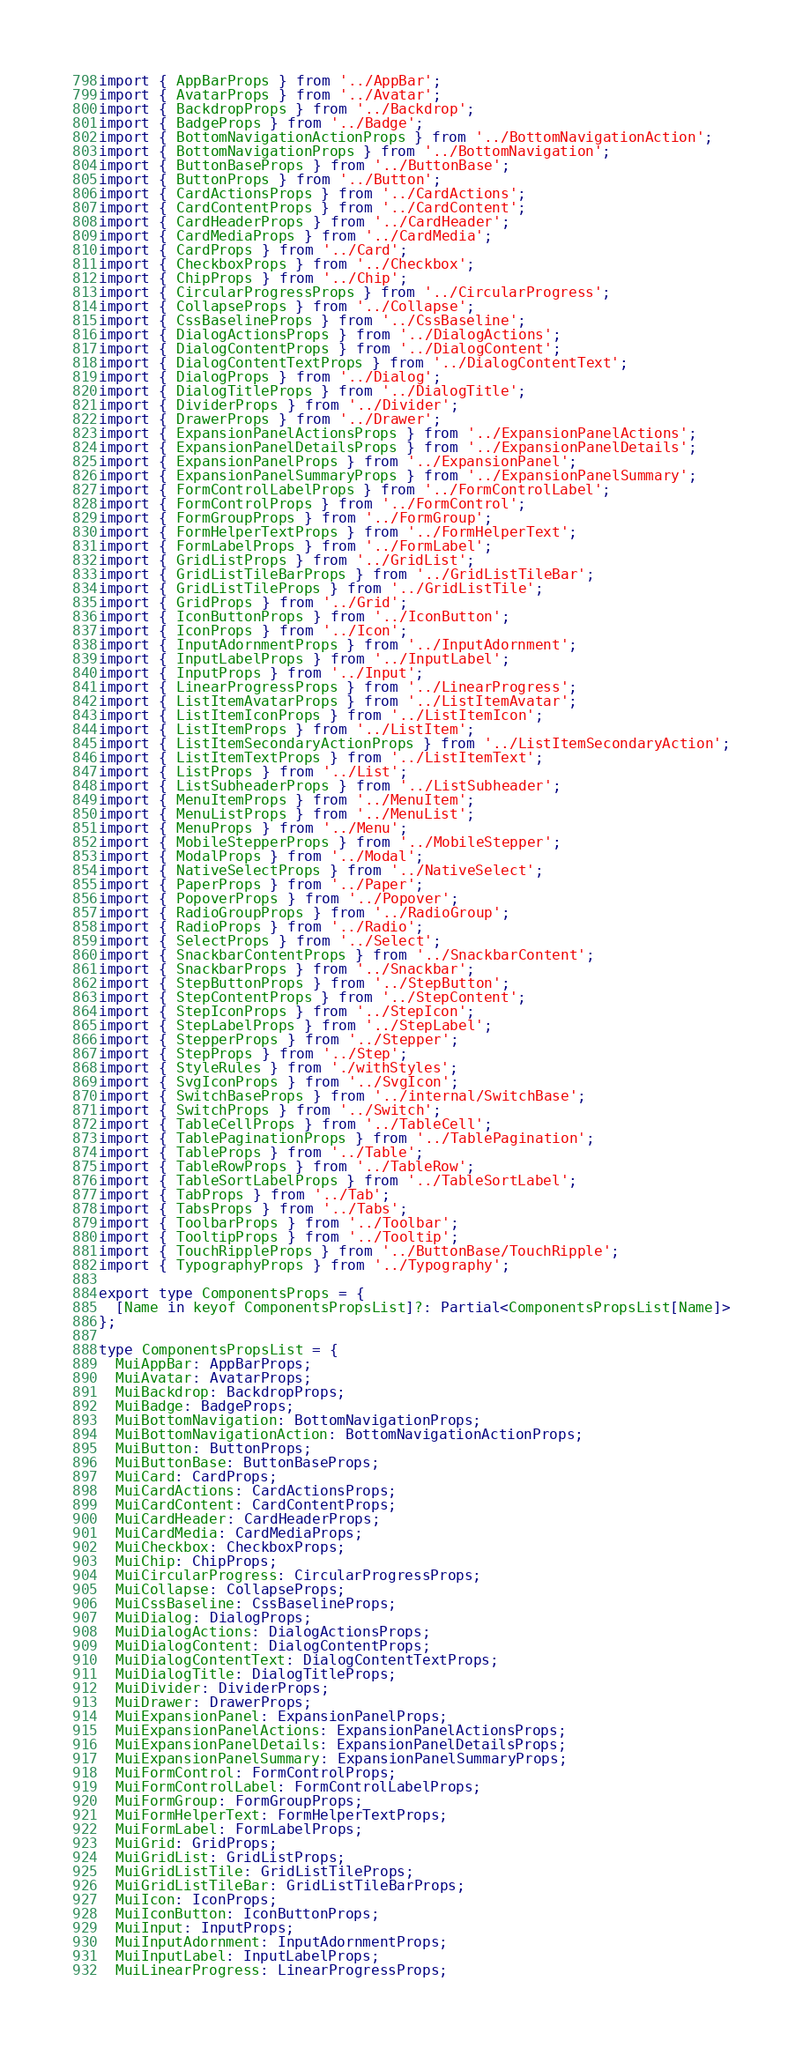Convert code to text. <code><loc_0><loc_0><loc_500><loc_500><_TypeScript_>import { AppBarProps } from '../AppBar';
import { AvatarProps } from '../Avatar';
import { BackdropProps } from '../Backdrop';
import { BadgeProps } from '../Badge';
import { BottomNavigationActionProps } from '../BottomNavigationAction';
import { BottomNavigationProps } from '../BottomNavigation';
import { ButtonBaseProps } from '../ButtonBase';
import { ButtonProps } from '../Button';
import { CardActionsProps } from '../CardActions';
import { CardContentProps } from '../CardContent';
import { CardHeaderProps } from '../CardHeader';
import { CardMediaProps } from '../CardMedia';
import { CardProps } from '../Card';
import { CheckboxProps } from '../Checkbox';
import { ChipProps } from '../Chip';
import { CircularProgressProps } from '../CircularProgress';
import { CollapseProps } from '../Collapse';
import { CssBaselineProps } from '../CssBaseline';
import { DialogActionsProps } from '../DialogActions';
import { DialogContentProps } from '../DialogContent';
import { DialogContentTextProps } from '../DialogContentText';
import { DialogProps } from '../Dialog';
import { DialogTitleProps } from '../DialogTitle';
import { DividerProps } from '../Divider';
import { DrawerProps } from '../Drawer';
import { ExpansionPanelActionsProps } from '../ExpansionPanelActions';
import { ExpansionPanelDetailsProps } from '../ExpansionPanelDetails';
import { ExpansionPanelProps } from '../ExpansionPanel';
import { ExpansionPanelSummaryProps } from '../ExpansionPanelSummary';
import { FormControlLabelProps } from '../FormControlLabel';
import { FormControlProps } from '../FormControl';
import { FormGroupProps } from '../FormGroup';
import { FormHelperTextProps } from '../FormHelperText';
import { FormLabelProps } from '../FormLabel';
import { GridListProps } from '../GridList';
import { GridListTileBarProps } from '../GridListTileBar';
import { GridListTileProps } from '../GridListTile';
import { GridProps } from '../Grid';
import { IconButtonProps } from '../IconButton';
import { IconProps } from '../Icon';
import { InputAdornmentProps } from '../InputAdornment';
import { InputLabelProps } from '../InputLabel';
import { InputProps } from '../Input';
import { LinearProgressProps } from '../LinearProgress';
import { ListItemAvatarProps } from '../ListItemAvatar';
import { ListItemIconProps } from '../ListItemIcon';
import { ListItemProps } from '../ListItem';
import { ListItemSecondaryActionProps } from '../ListItemSecondaryAction';
import { ListItemTextProps } from '../ListItemText';
import { ListProps } from '../List';
import { ListSubheaderProps } from '../ListSubheader';
import { MenuItemProps } from '../MenuItem';
import { MenuListProps } from '../MenuList';
import { MenuProps } from '../Menu';
import { MobileStepperProps } from '../MobileStepper';
import { ModalProps } from '../Modal';
import { NativeSelectProps } from '../NativeSelect';
import { PaperProps } from '../Paper';
import { PopoverProps } from '../Popover';
import { RadioGroupProps } from '../RadioGroup';
import { RadioProps } from '../Radio';
import { SelectProps } from '../Select';
import { SnackbarContentProps } from '../SnackbarContent';
import { SnackbarProps } from '../Snackbar';
import { StepButtonProps } from '../StepButton';
import { StepContentProps } from '../StepContent';
import { StepIconProps } from '../StepIcon';
import { StepLabelProps } from '../StepLabel';
import { StepperProps } from '../Stepper';
import { StepProps } from '../Step';
import { StyleRules } from './withStyles';
import { SvgIconProps } from '../SvgIcon';
import { SwitchBaseProps } from '../internal/SwitchBase';
import { SwitchProps } from '../Switch';
import { TableCellProps } from '../TableCell';
import { TablePaginationProps } from '../TablePagination';
import { TableProps } from '../Table';
import { TableRowProps } from '../TableRow';
import { TableSortLabelProps } from '../TableSortLabel';
import { TabProps } from '../Tab';
import { TabsProps } from '../Tabs';
import { ToolbarProps } from '../Toolbar';
import { TooltipProps } from '../Tooltip';
import { TouchRippleProps } from '../ButtonBase/TouchRipple';
import { TypographyProps } from '../Typography';

export type ComponentsProps = {
  [Name in keyof ComponentsPropsList]?: Partial<ComponentsPropsList[Name]>
};

type ComponentsPropsList = {
  MuiAppBar: AppBarProps;
  MuiAvatar: AvatarProps;
  MuiBackdrop: BackdropProps;
  MuiBadge: BadgeProps;
  MuiBottomNavigation: BottomNavigationProps;
  MuiBottomNavigationAction: BottomNavigationActionProps;
  MuiButton: ButtonProps;
  MuiButtonBase: ButtonBaseProps;
  MuiCard: CardProps;
  MuiCardActions: CardActionsProps;
  MuiCardContent: CardContentProps;
  MuiCardHeader: CardHeaderProps;
  MuiCardMedia: CardMediaProps;
  MuiCheckbox: CheckboxProps;
  MuiChip: ChipProps;
  MuiCircularProgress: CircularProgressProps;
  MuiCollapse: CollapseProps;
  MuiCssBaseline: CssBaselineProps;
  MuiDialog: DialogProps;
  MuiDialogActions: DialogActionsProps;
  MuiDialogContent: DialogContentProps;
  MuiDialogContentText: DialogContentTextProps;
  MuiDialogTitle: DialogTitleProps;
  MuiDivider: DividerProps;
  MuiDrawer: DrawerProps;
  MuiExpansionPanel: ExpansionPanelProps;
  MuiExpansionPanelActions: ExpansionPanelActionsProps;
  MuiExpansionPanelDetails: ExpansionPanelDetailsProps;
  MuiExpansionPanelSummary: ExpansionPanelSummaryProps;
  MuiFormControl: FormControlProps;
  MuiFormControlLabel: FormControlLabelProps;
  MuiFormGroup: FormGroupProps;
  MuiFormHelperText: FormHelperTextProps;
  MuiFormLabel: FormLabelProps;
  MuiGrid: GridProps;
  MuiGridList: GridListProps;
  MuiGridListTile: GridListTileProps;
  MuiGridListTileBar: GridListTileBarProps;
  MuiIcon: IconProps;
  MuiIconButton: IconButtonProps;
  MuiInput: InputProps;
  MuiInputAdornment: InputAdornmentProps;
  MuiInputLabel: InputLabelProps;
  MuiLinearProgress: LinearProgressProps;</code> 